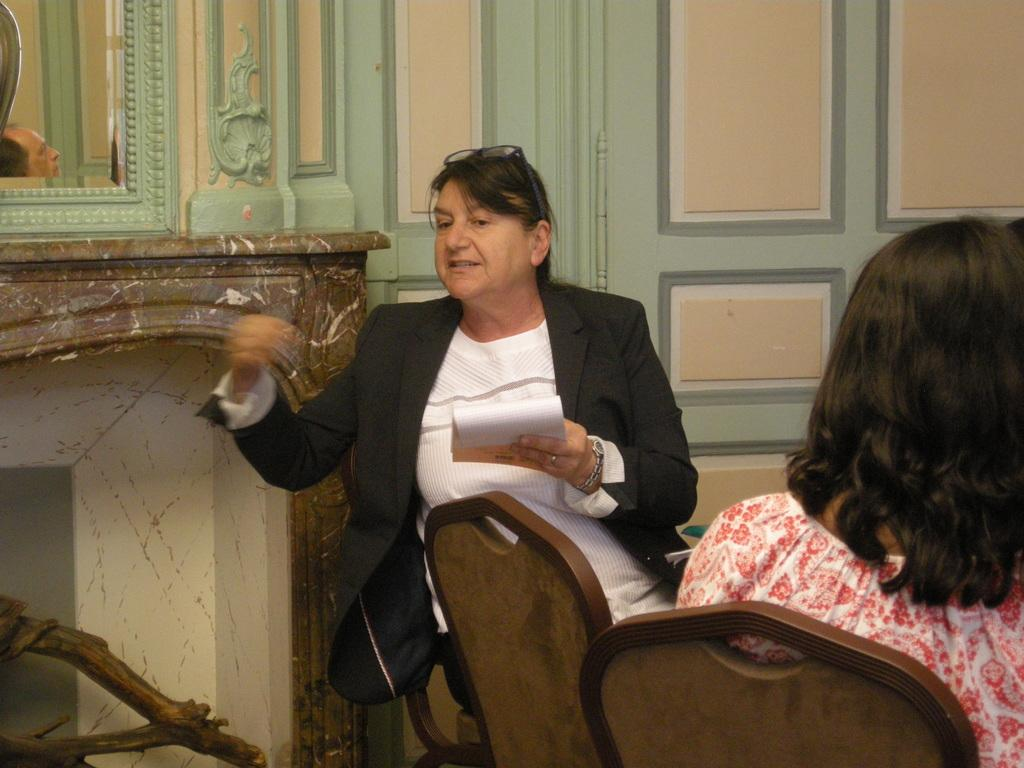Who can be seen in the image? There are people in the image. Can you describe the woman in the image? A woman is present in the image, and she is holding a book. What are the people in the image doing? The people are seated on chairs. What type of impulse can be seen affecting the woman in the image? There is no mention of any impulse affecting the woman in the image. What memories does the book in the image evoke for the woman? The image does not provide any information about the woman's memories or the content of the book. 